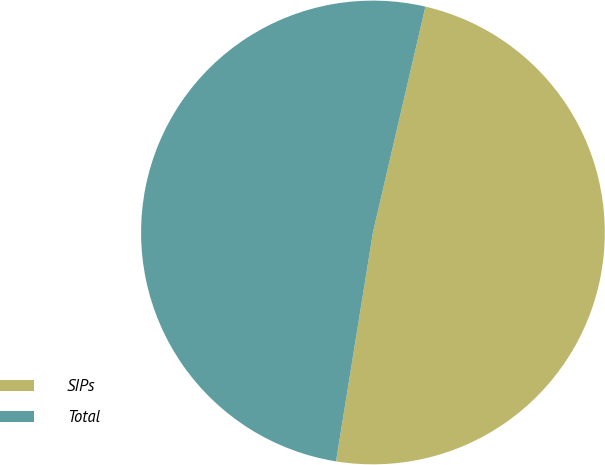<chart> <loc_0><loc_0><loc_500><loc_500><pie_chart><fcel>SIPs<fcel>Total<nl><fcel>48.91%<fcel>51.09%<nl></chart> 